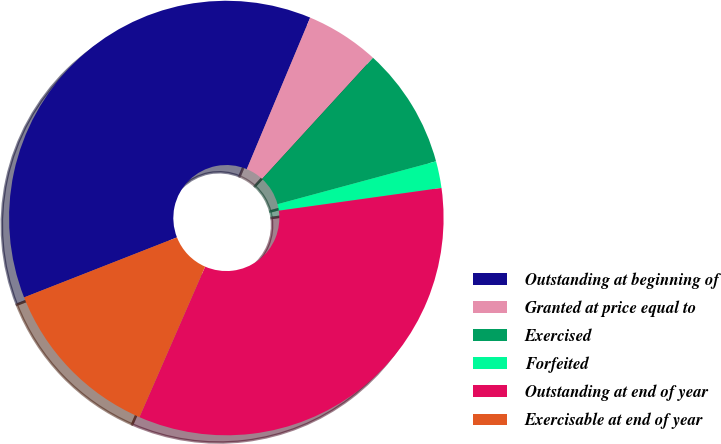<chart> <loc_0><loc_0><loc_500><loc_500><pie_chart><fcel>Outstanding at beginning of<fcel>Granted at price equal to<fcel>Exercised<fcel>Forfeited<fcel>Outstanding at end of year<fcel>Exercisable at end of year<nl><fcel>37.26%<fcel>5.49%<fcel>9.0%<fcel>1.99%<fcel>33.76%<fcel>12.5%<nl></chart> 